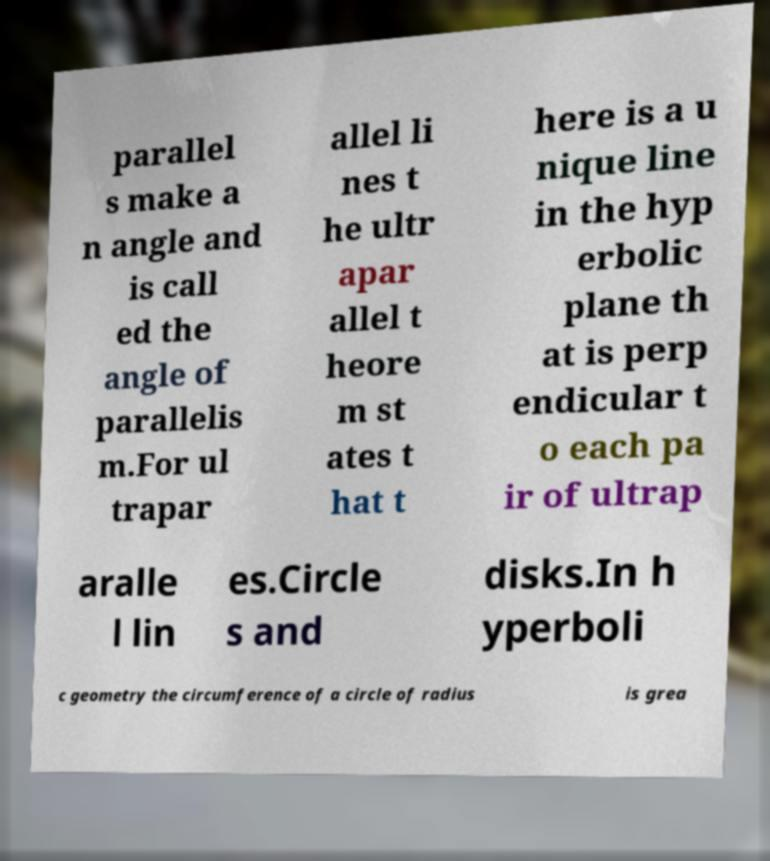Could you extract and type out the text from this image? parallel s make a n angle and is call ed the angle of parallelis m.For ul trapar allel li nes t he ultr apar allel t heore m st ates t hat t here is a u nique line in the hyp erbolic plane th at is perp endicular t o each pa ir of ultrap aralle l lin es.Circle s and disks.In h yperboli c geometry the circumference of a circle of radius is grea 